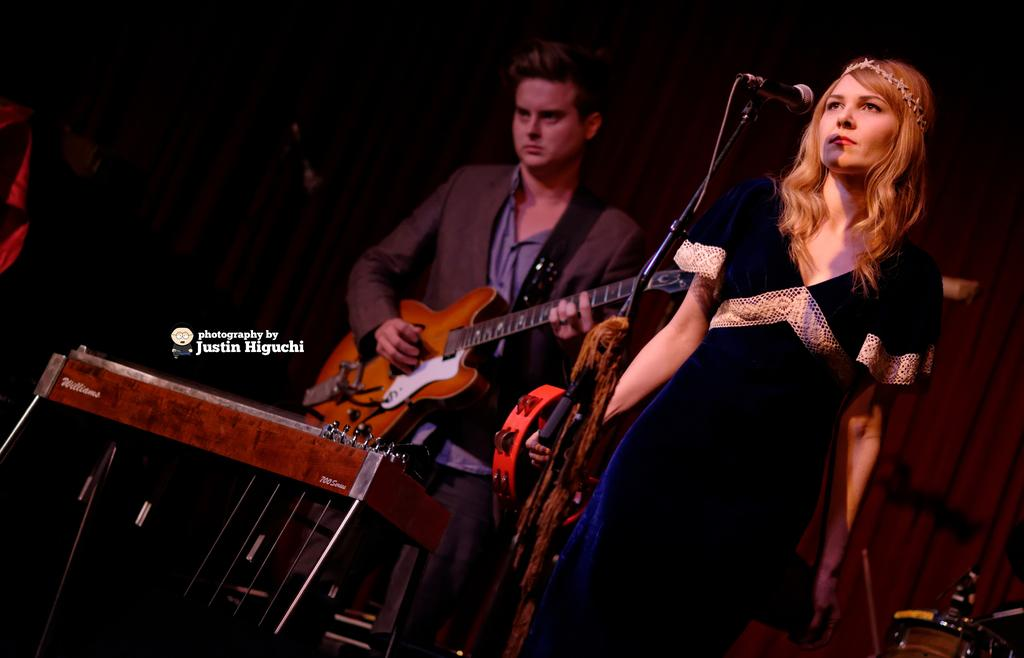Who is present in the image? There is a woman and a man in the image. What is the woman doing in the image? The woman is standing near a microphone. What is the man holding in the image? The man is holding a guitar. What type of calculator is the woman using in the image? There is no calculator present in the image; the woman is standing near a microphone. How many songs can be heard playing in the background of the image? There is no audio information provided in the image, so it is not possible to determine how many songs might be playing in the background. 